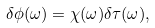Convert formula to latex. <formula><loc_0><loc_0><loc_500><loc_500>\delta \phi ( \omega ) = \chi ( \omega ) \delta \tau ( \omega ) ,</formula> 